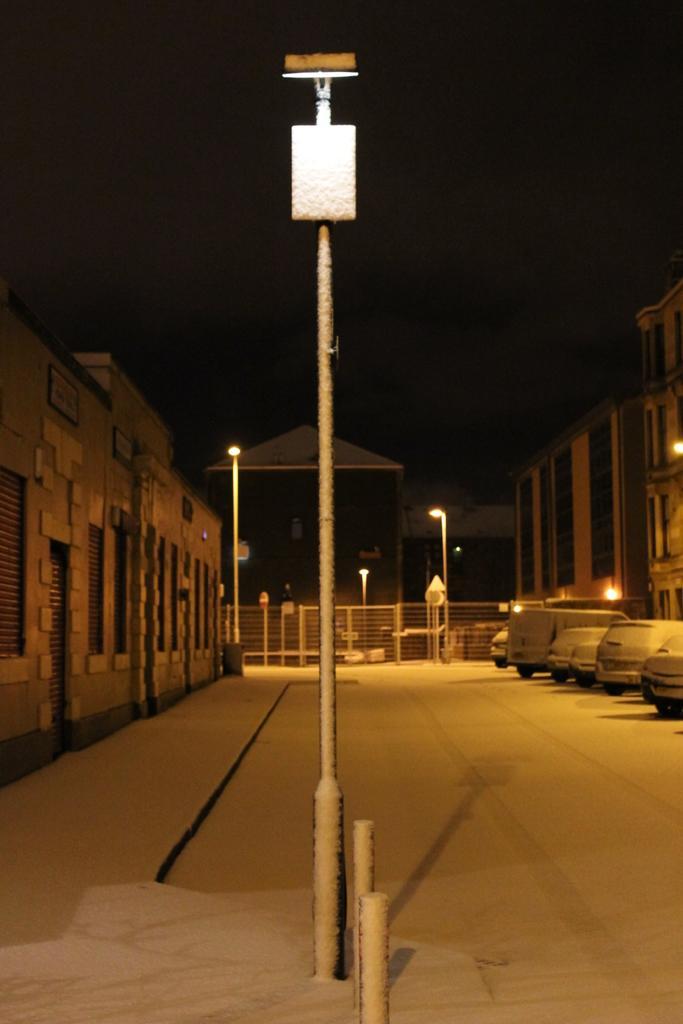Can you describe this image briefly? This image is clicked on the road. In the center there is a street light pole. To the right there are vehicles parked on the road. On the either sides of the image their buildings. In the background there are street light poles and a railing. At the top there is the sky. 